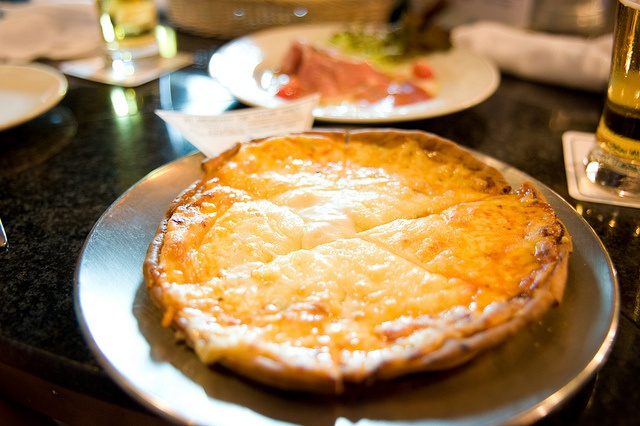Describe the objects in this image and their specific colors. I can see dining table in black, white, maroon, orange, and tan tones, pizza in black, orange, tan, and ivory tones, and cup in black, olive, maroon, and orange tones in this image. 